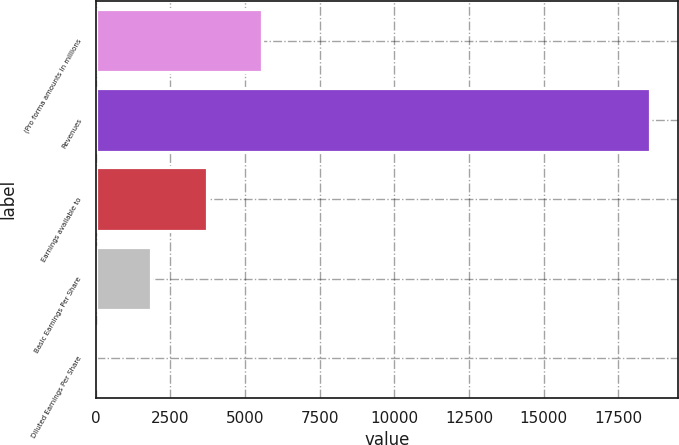Convert chart to OTSL. <chart><loc_0><loc_0><loc_500><loc_500><bar_chart><fcel>(Pro forma amounts in millions<fcel>Revenues<fcel>Earnings available to<fcel>Basic Earnings Per Share<fcel>Diluted Earnings Per Share<nl><fcel>5572.68<fcel>18569<fcel>3716.06<fcel>1859.44<fcel>2.82<nl></chart> 